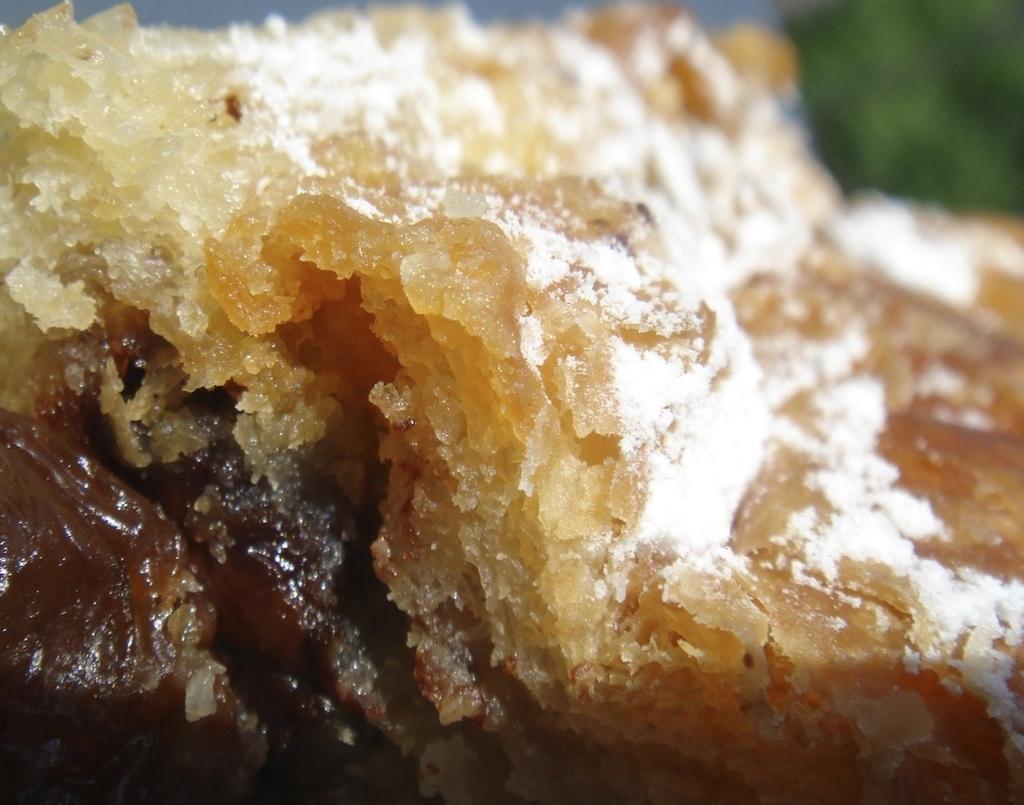How would you summarize this image in a sentence or two? In the center of the image there is a food item. 